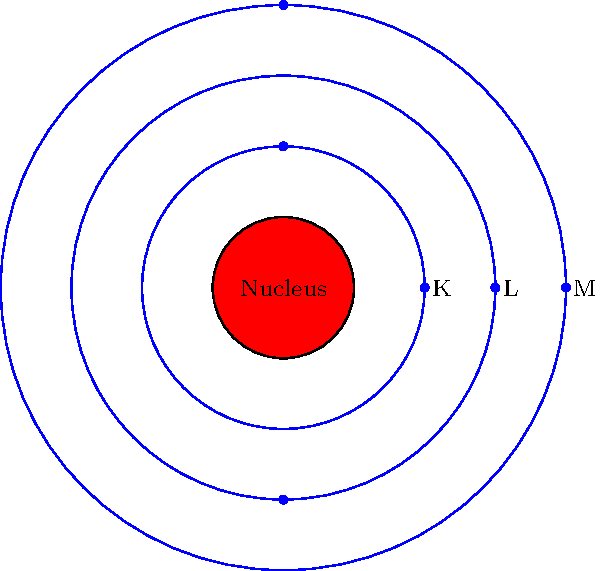In the atomic model shown, which shell would most likely contain the valence electrons, and how does this relate to an atom's chemical reactivity? To answer this question, let's break it down step-by-step:

1. Atomic structure: The diagram shows an atom with a nucleus and three electron shells (K, L, and M).

2. Electron shells:
   - K shell (innermost): Can hold up to 2 electrons
   - L shell (middle): Can hold up to 8 electrons
   - M shell (outermost in this diagram): Can hold up to 18 electrons

3. Valence electrons: These are the electrons in the outermost occupied shell of an atom.

4. In this diagram, the M shell is the outermost shell, so it would most likely contain the valence electrons.

5. Chemical reactivity:
   - Valence electrons determine an atom's chemical properties and reactivity.
   - Atoms tend to gain, lose, or share electrons to achieve a stable electron configuration (usually 8 electrons in the outermost shell, known as the "octet rule").

6. Relationship to reactivity:
   - Atoms with nearly full or nearly empty outermost shells are typically more reactive.
   - The easier it is for an atom to gain, lose, or share electrons from its outermost shell, the more reactive it tends to be.

7. In astrophysics, understanding atomic structure and reactivity is crucial for:
   - Studying stellar nucleosynthesis (formation of elements in stars)
   - Analyzing spectral lines to determine composition of celestial bodies
   - Understanding the chemistry of interstellar medium
Answer: M shell; valence electrons in the outermost shell determine reactivity. 